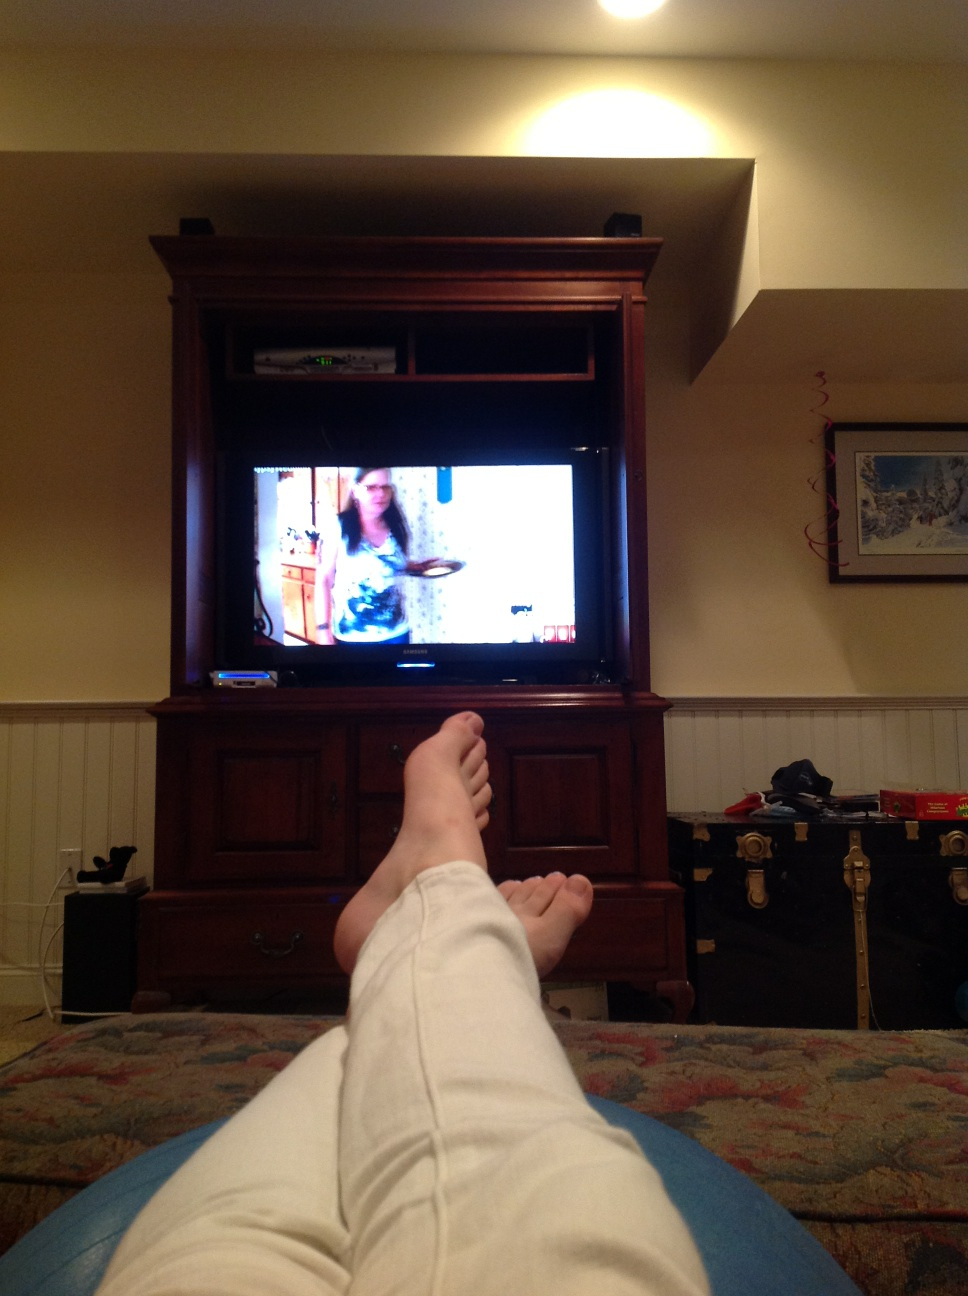Describe any visible tech or gadgets besides the TV. Besides the large flat screen television, I can see a couple of remote controls on the coffee table and what looks like a speaker or soundbar on top of the media stand below the TV. 